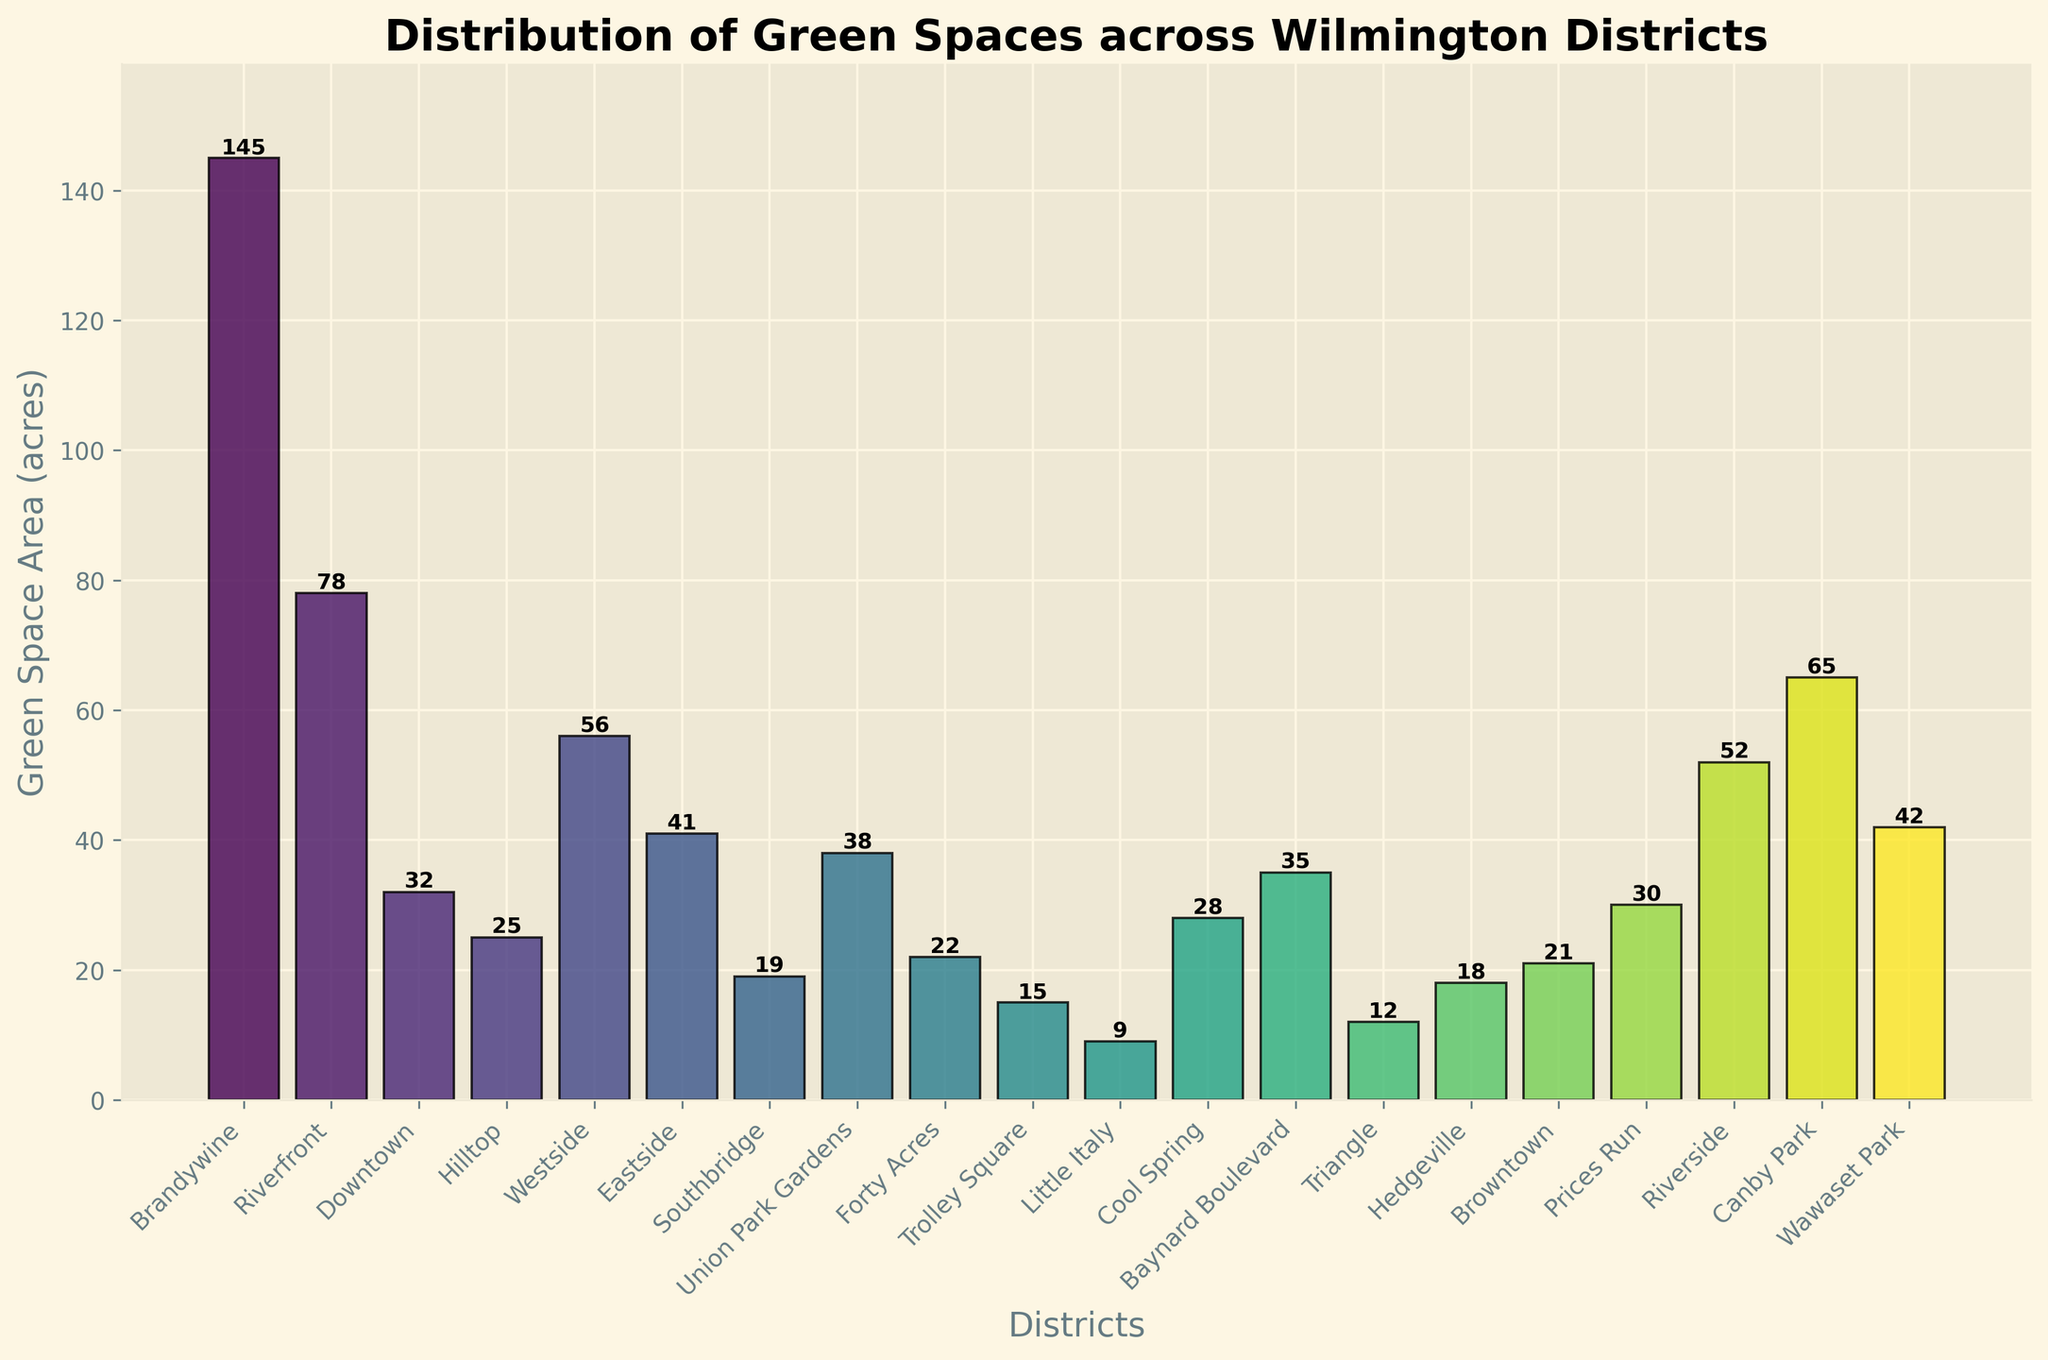What's the district with the largest green space area? Look at the heights of the bars and find the district with the tallest bar. 'Brandywine' has the tallest bar indicating the largest green space area.
Answer: Brandywine Which two districts have the smallest green space areas? Identify the two shortest bars. 'Little Italy' and 'Trolley Square' have the shortest bars.
Answer: Little Italy, Trolley Square What is the combined green space area of Brandywine and Riverfront districts? Look at the heights of the bars for Brandywine and Riverfront districts. Brandywine has 145 acres and Riverfront has 78 acres. Combine these values: 145 + 78.
Answer: 223 acres Which district has a green space area four times larger than Southbridge? Identify the green space area of Southbridge (19 acres) and look for a bar with a height around four times this value (76 acres). 'Brandywine' is the closest with 145 acres.
Answer: None (no district with exactly 76 acres, but Brandywine is closest) Are there districts with nearly equal green space areas? Compare the heights of bars to see which ones are of similar height. 'Hedgeville' and 'Browntown' both have around 18 and 21 acres of green space.
Answer: Hedgeville, Browntown How much more green space does Canby Park have compared to Union Park Gardens? Identify the heights of the bars for Canby Park (65 acres) and Union Park Gardens (38 acres). Subtract the smaller from the larger: 65 - 38.
Answer: 27 acres Which district has the most diverse color representation in the plot? Examine the colors of the bars. All bars are colored using the viridis colormap creating a gradient effect, with 'Brandywine' likely having the most varied color as it represents the highest value.
Answer: Brandywine What is the fifth highest green space area among the districts? Rank the heights of the bars from tallest to shortest. The fifth highest green space area is in 'Riverfront' with 78 acres.
Answer: Riverfront How many districts have a green space area greater than 50 acres? Count the number of bars with heights above the 50-acre marker. Brandywine, Canby Park, Riverfront, Westside, and Riverside exceed this threshold.
Answer: 5 districts 